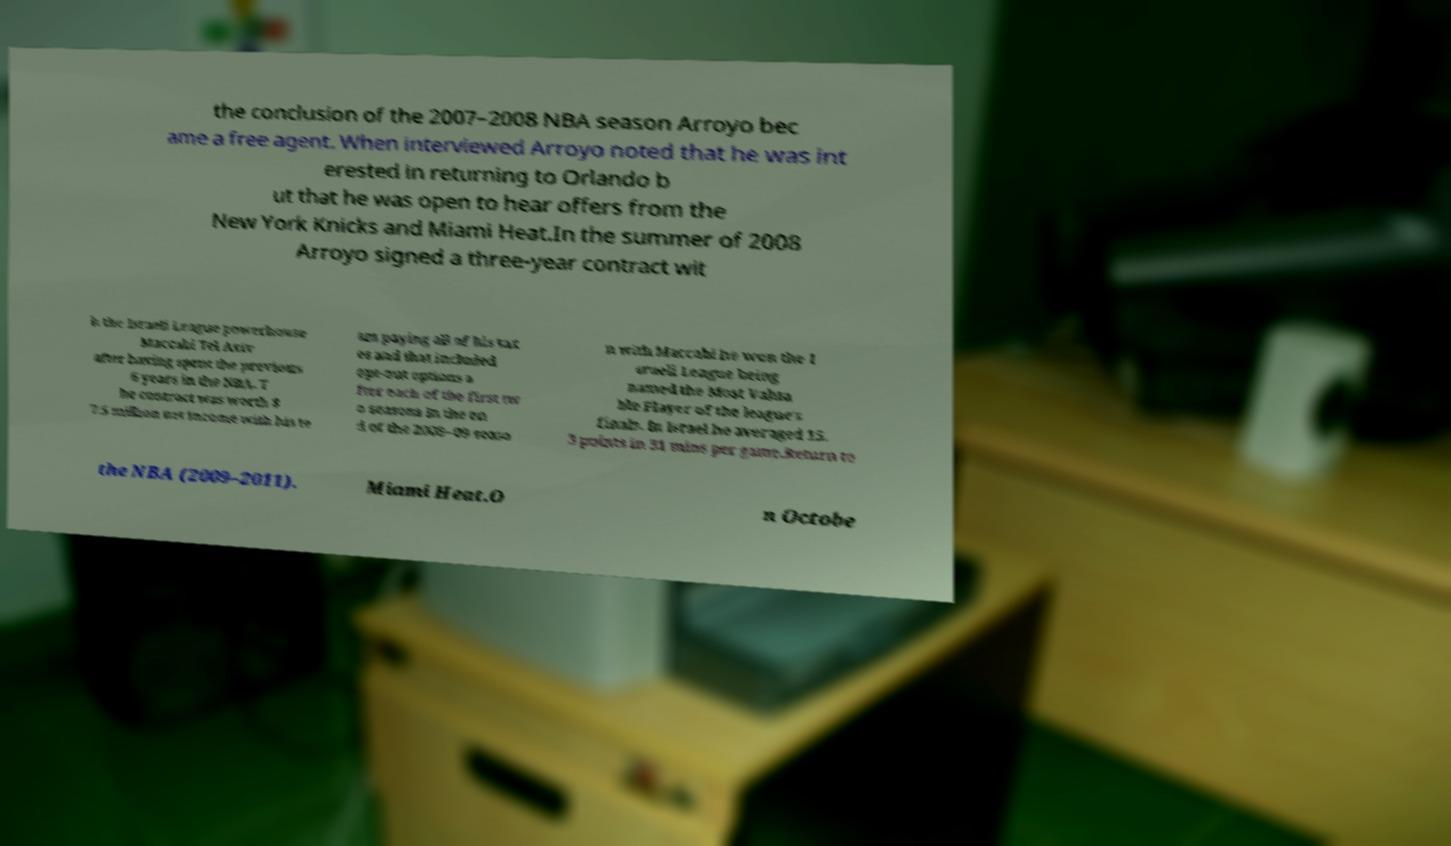Please identify and transcribe the text found in this image. the conclusion of the 2007–2008 NBA season Arroyo bec ame a free agent. When interviewed Arroyo noted that he was int erested in returning to Orlando b ut that he was open to hear offers from the New York Knicks and Miami Heat.In the summer of 2008 Arroyo signed a three-year contract wit h the Israeli League powerhouse Maccabi Tel Aviv after having spent the previous 6 years in the NBA. T he contract was worth $ 7.5 million net income with his te am paying all of his tax es and that included opt-out options a fter each of the first tw o seasons In the en d of the 2008–09 seaso n with Maccabi he won the I sraeli League being named the Most Valua ble Player of the league's finals. In Israel he averaged 15. 3 points in 31 mins per game.Return to the NBA (2009–2011). Miami Heat.O n Octobe 